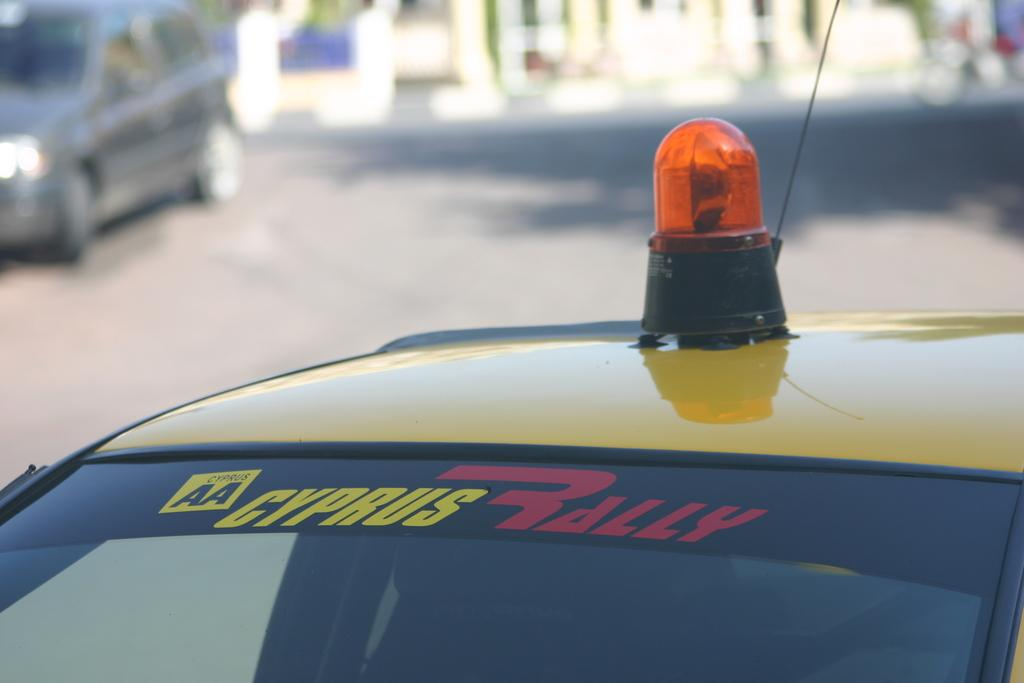<image>
Present a compact description of the photo's key features. A yellow Cyprus Rally Car with an orange light on top. 